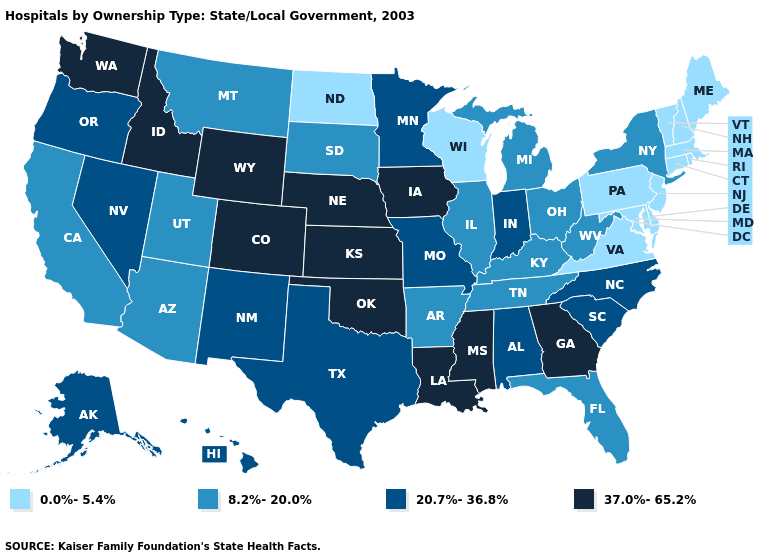Name the states that have a value in the range 20.7%-36.8%?
Give a very brief answer. Alabama, Alaska, Hawaii, Indiana, Minnesota, Missouri, Nevada, New Mexico, North Carolina, Oregon, South Carolina, Texas. Does California have a lower value than Minnesota?
Be succinct. Yes. What is the highest value in the MidWest ?
Answer briefly. 37.0%-65.2%. Which states have the highest value in the USA?
Give a very brief answer. Colorado, Georgia, Idaho, Iowa, Kansas, Louisiana, Mississippi, Nebraska, Oklahoma, Washington, Wyoming. What is the value of Massachusetts?
Answer briefly. 0.0%-5.4%. Does the first symbol in the legend represent the smallest category?
Quick response, please. Yes. Among the states that border Vermont , which have the lowest value?
Be succinct. Massachusetts, New Hampshire. Which states have the highest value in the USA?
Short answer required. Colorado, Georgia, Idaho, Iowa, Kansas, Louisiana, Mississippi, Nebraska, Oklahoma, Washington, Wyoming. What is the value of Idaho?
Short answer required. 37.0%-65.2%. Which states hav the highest value in the Northeast?
Concise answer only. New York. Name the states that have a value in the range 20.7%-36.8%?
Give a very brief answer. Alabama, Alaska, Hawaii, Indiana, Minnesota, Missouri, Nevada, New Mexico, North Carolina, Oregon, South Carolina, Texas. What is the value of Alaska?
Keep it brief. 20.7%-36.8%. Name the states that have a value in the range 8.2%-20.0%?
Concise answer only. Arizona, Arkansas, California, Florida, Illinois, Kentucky, Michigan, Montana, New York, Ohio, South Dakota, Tennessee, Utah, West Virginia. Among the states that border West Virginia , which have the lowest value?
Write a very short answer. Maryland, Pennsylvania, Virginia. What is the value of Florida?
Quick response, please. 8.2%-20.0%. 